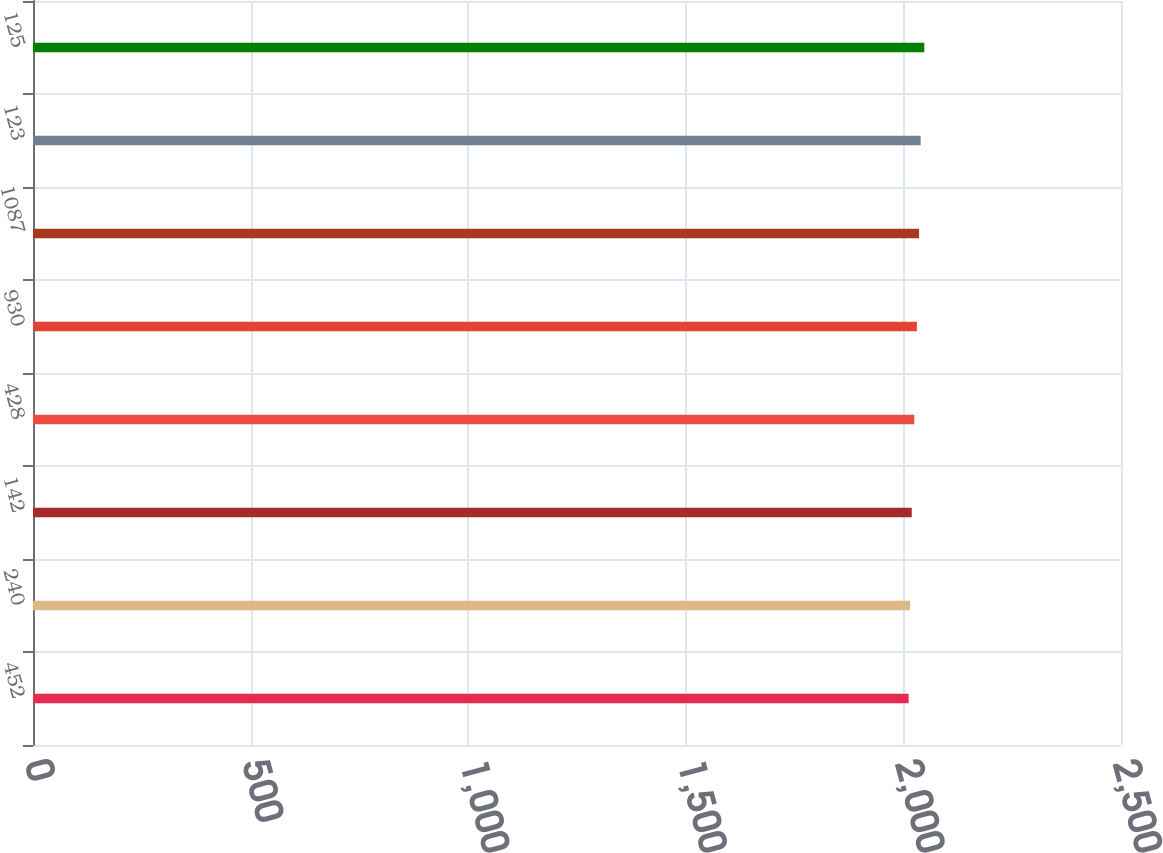Convert chart. <chart><loc_0><loc_0><loc_500><loc_500><bar_chart><fcel>452<fcel>240<fcel>142<fcel>428<fcel>930<fcel>1087<fcel>123<fcel>125<nl><fcel>2012<fcel>2015.6<fcel>2019.2<fcel>2025<fcel>2031<fcel>2036<fcel>2039.6<fcel>2048<nl></chart> 